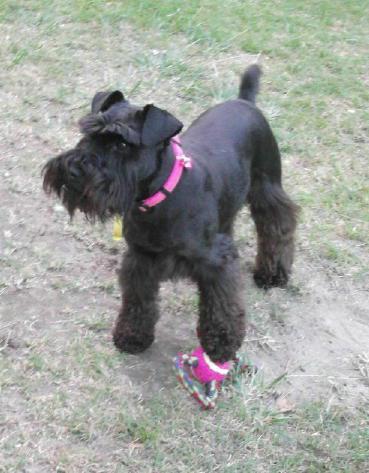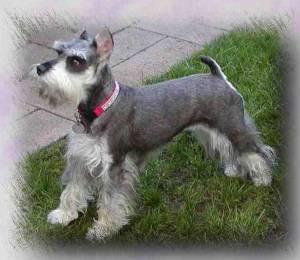The first image is the image on the left, the second image is the image on the right. Examine the images to the left and right. Is the description "there is a black dog in the image on the right" accurate? Answer yes or no. No. 